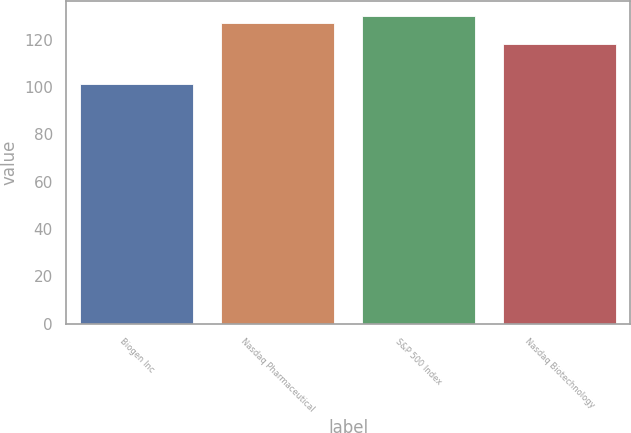<chart> <loc_0><loc_0><loc_500><loc_500><bar_chart><fcel>Biogen Inc<fcel>Nasdaq Pharmaceutical<fcel>S&P 500 Index<fcel>Nasdaq Biotechnology<nl><fcel>101.43<fcel>127.04<fcel>129.8<fcel>118.15<nl></chart> 